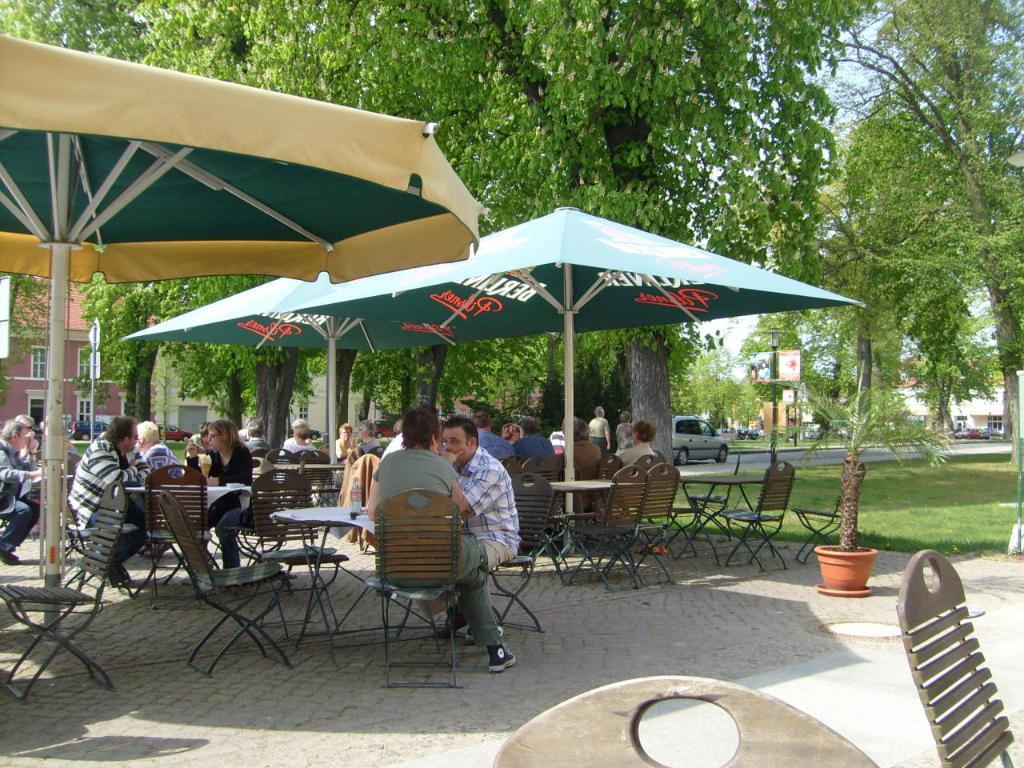What are the people in the image doing? The persons sitting on chairs in the center of the image. What provides shade for the people sitting on chairs? The chairs are under umbrellas. What can be seen in the background of the image? There are trees, a car, a road, buildings, and the sky visible in the background of the image. What type of joke can be heard being told by the person sitting on the chair in the image? There is no indication in the image that a joke is being told, so it cannot be determined from the picture. 